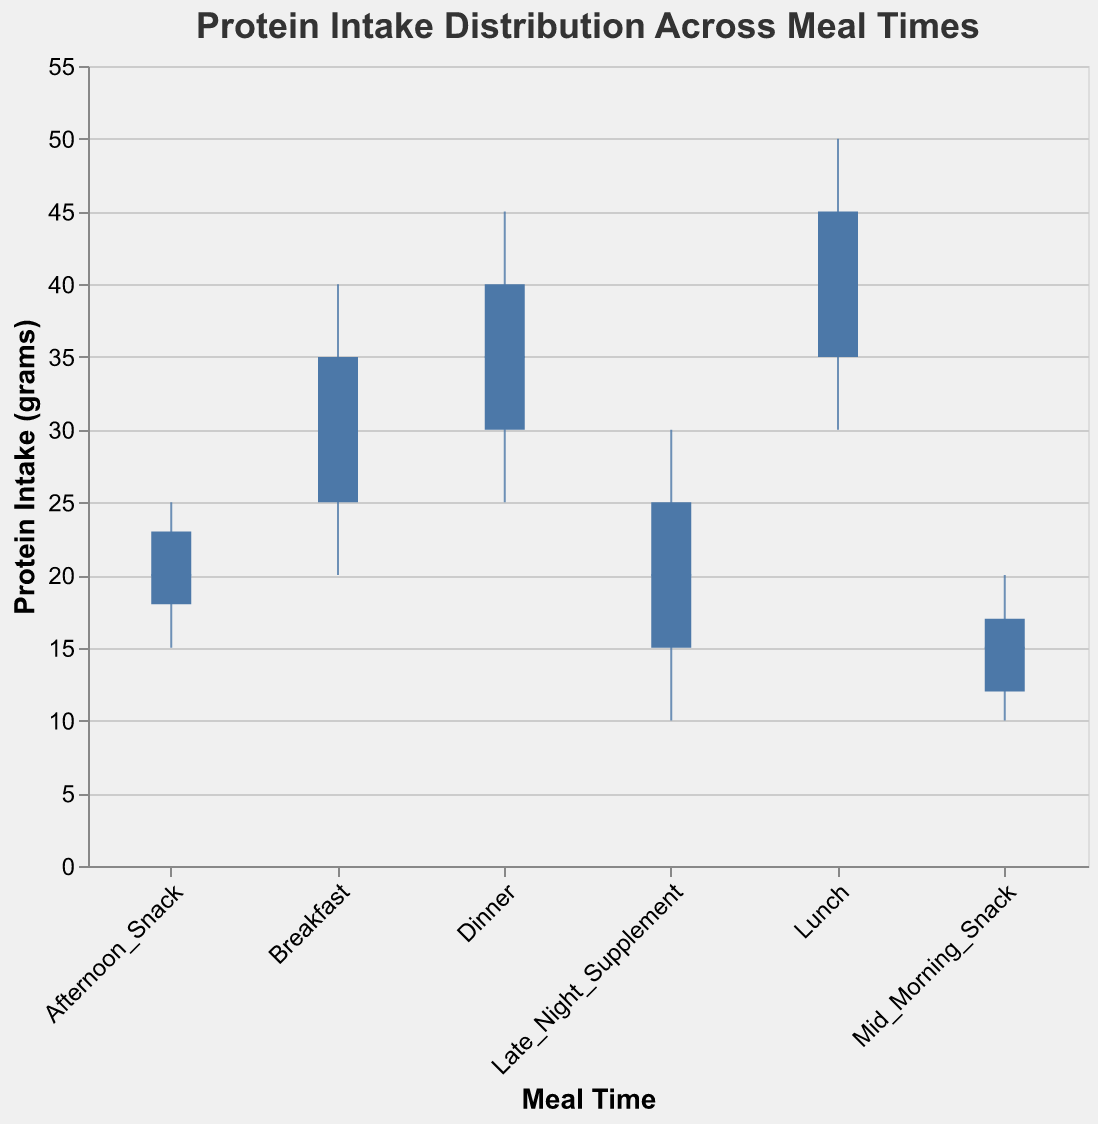What is the title of the figure? The title of the figure is usually placed at the top and is meant to describe what the figure is about. Based on the visual elements, look for text formatted as a heading.
Answer: Protein Intake Distribution Across Meal Times What does the x-axis represent? The x-axis typically represents categorical data in a candlestick plot. In this figure, it lists meal times as categories.
Answer: Meal Time Which meal time has the highest median protein intake? To determine this, compare the median protein intake values for each meal time. The median is indicated by the white tick mark in the candlestick.
Answer: Lunch What is the minimum protein intake for Dinner? The minimum protein intake is represented by the bottom of the vertical line extending from the bar for the "Dinner" meal time.
Answer: 25 grams Which meal time has the largest range in protein intake? The range is calculated by subtracting the minimum protein intake from the maximum protein intake for each meal time. Identify the meal time with the largest difference. Dinner and Late Night Supplement both have the largest range, spanning from minimum to maximum.
Answer: Lunch and Late Night Supplement During which meal time is the third quartile median the highest? The third quartile median is represented by the top of the colored bar in the candlestick. Compare these values across meal times.
Answer: Lunch What is the median protein intake for Afternoon Snack? The median protein intake is indicated by the white tick mark in the candlestick for the "Afternoon Snack" meal time.
Answer: 20 grams Is the median protein intake higher for Breakfast or Dinner? Compare the white tick marks representing the median protein intake for "Breakfast" and "Dinner".
Answer: Dinner What is the first quartile median protein intake for Breakfast? The first quartile median is represented by the bottom of the colored bar in the candlestick for the "Breakfast" meal time.
Answer: 25 grams How does the protein intake distribution for Mid Morning Snack compare to Afternoon Snack in terms of range and median? For the range, compare the differences between the maximum and minimum values for both meal times. For the median, compare the positions of the white tick marks. Mid_Morning_Snack has a range from 10 to 20 (10) and median of 15, while Afternoon_Snack has a range from 15 to 25 (10) and median of 20.
Answer: Mid Morning Snack has a lower median but similar range compared to Afternoon Snack 